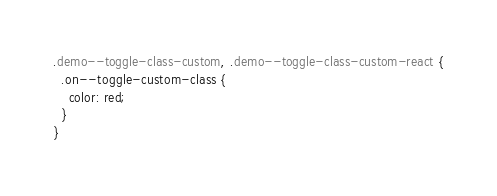Convert code to text. <code><loc_0><loc_0><loc_500><loc_500><_CSS_>.demo--toggle-class-custom, .demo--toggle-class-custom-react {
  .on--toggle-custom-class {
    color: red;
  }
}
</code> 